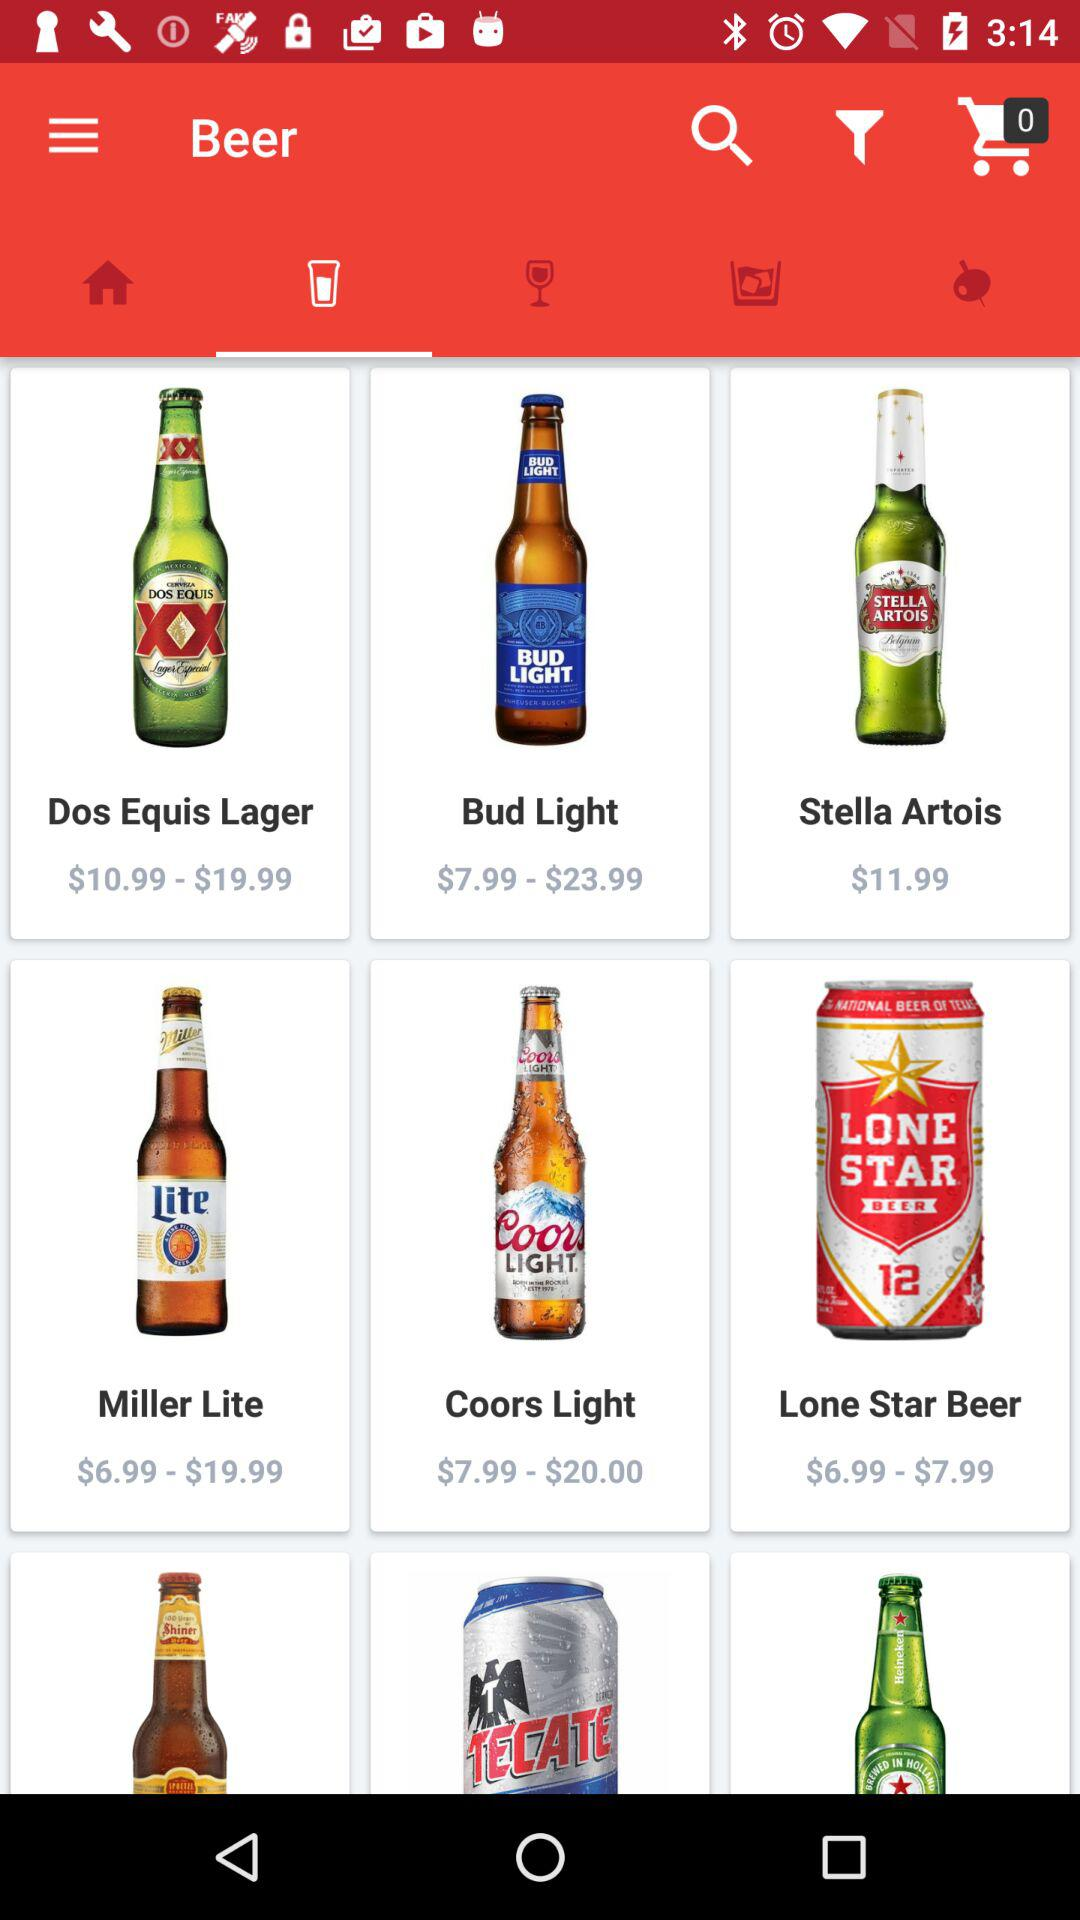Which tab is selected? The selected tab is "Beer". 